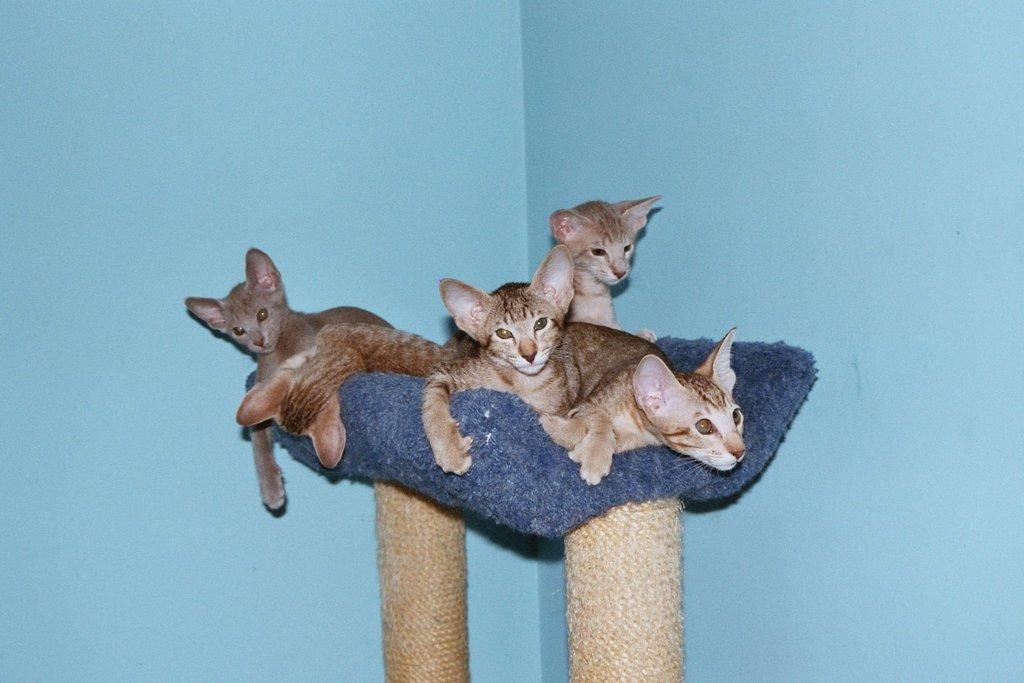Could you give a brief overview of what you see in this image? In this picture we can see poles and a group of cats on a cloth and in the background we can see walls. 